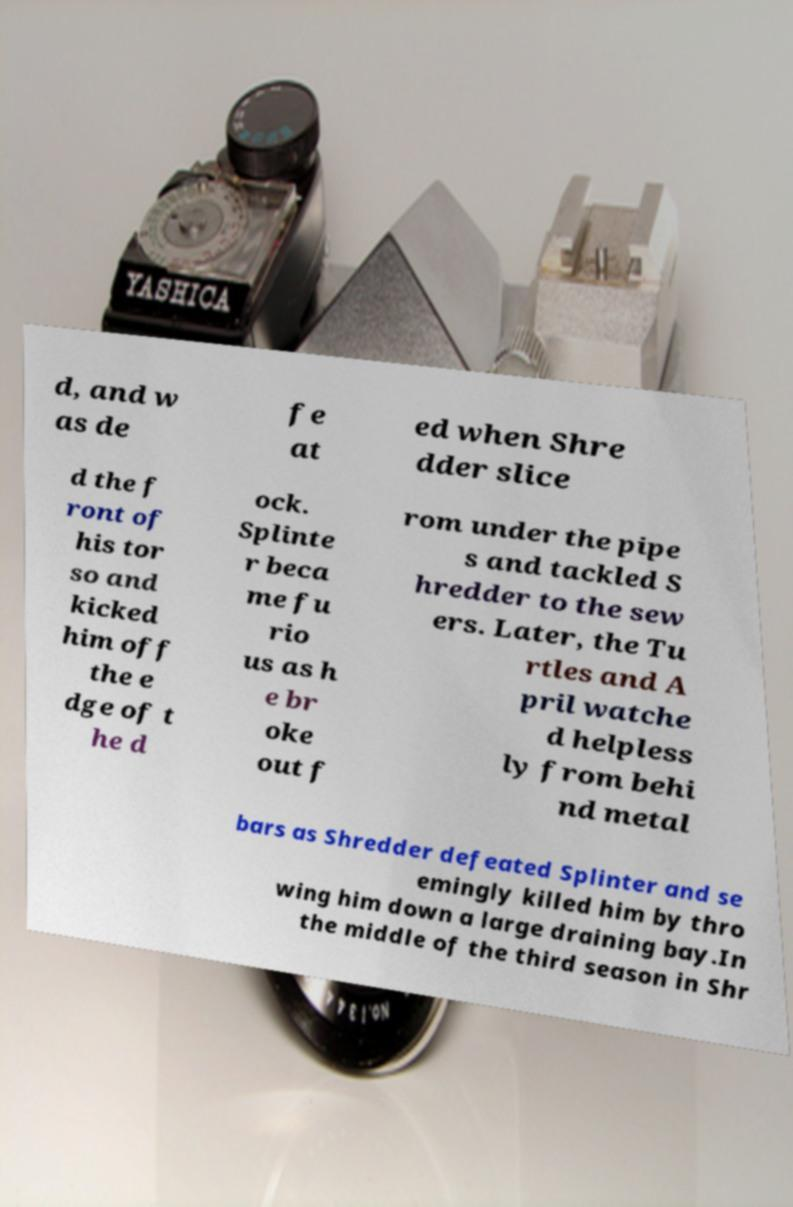I need the written content from this picture converted into text. Can you do that? d, and w as de fe at ed when Shre dder slice d the f ront of his tor so and kicked him off the e dge of t he d ock. Splinte r beca me fu rio us as h e br oke out f rom under the pipe s and tackled S hredder to the sew ers. Later, the Tu rtles and A pril watche d helpless ly from behi nd metal bars as Shredder defeated Splinter and se emingly killed him by thro wing him down a large draining bay.In the middle of the third season in Shr 